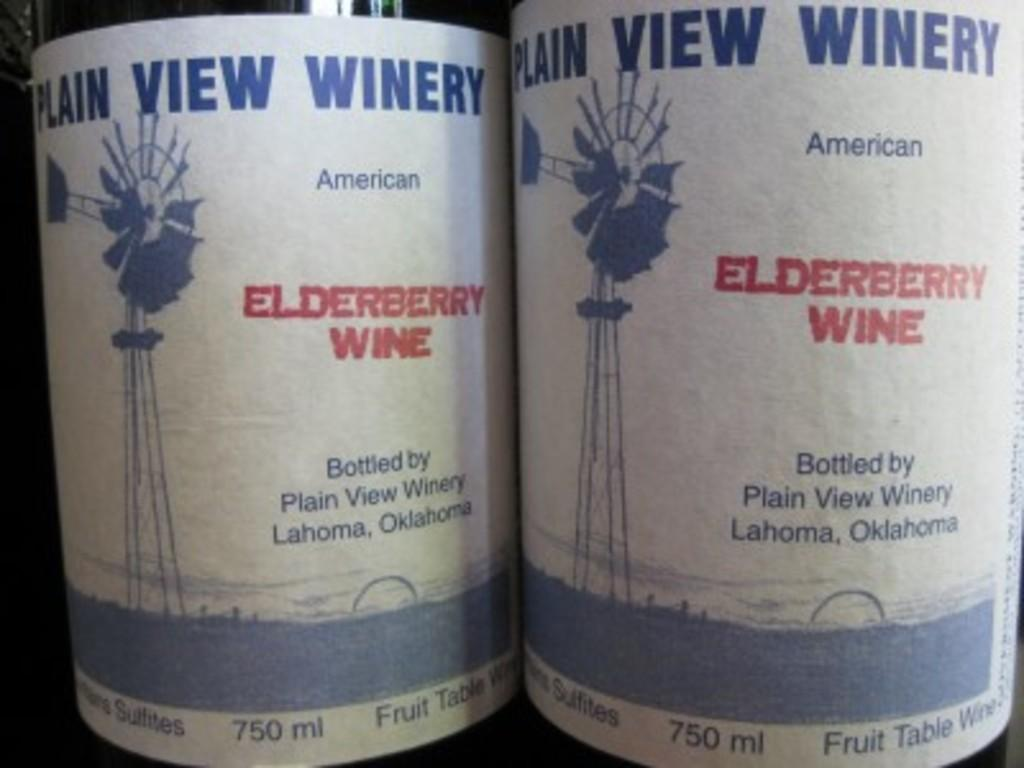<image>
Give a short and clear explanation of the subsequent image. Plain View Winery is located in Oklahoma according to their labels. 